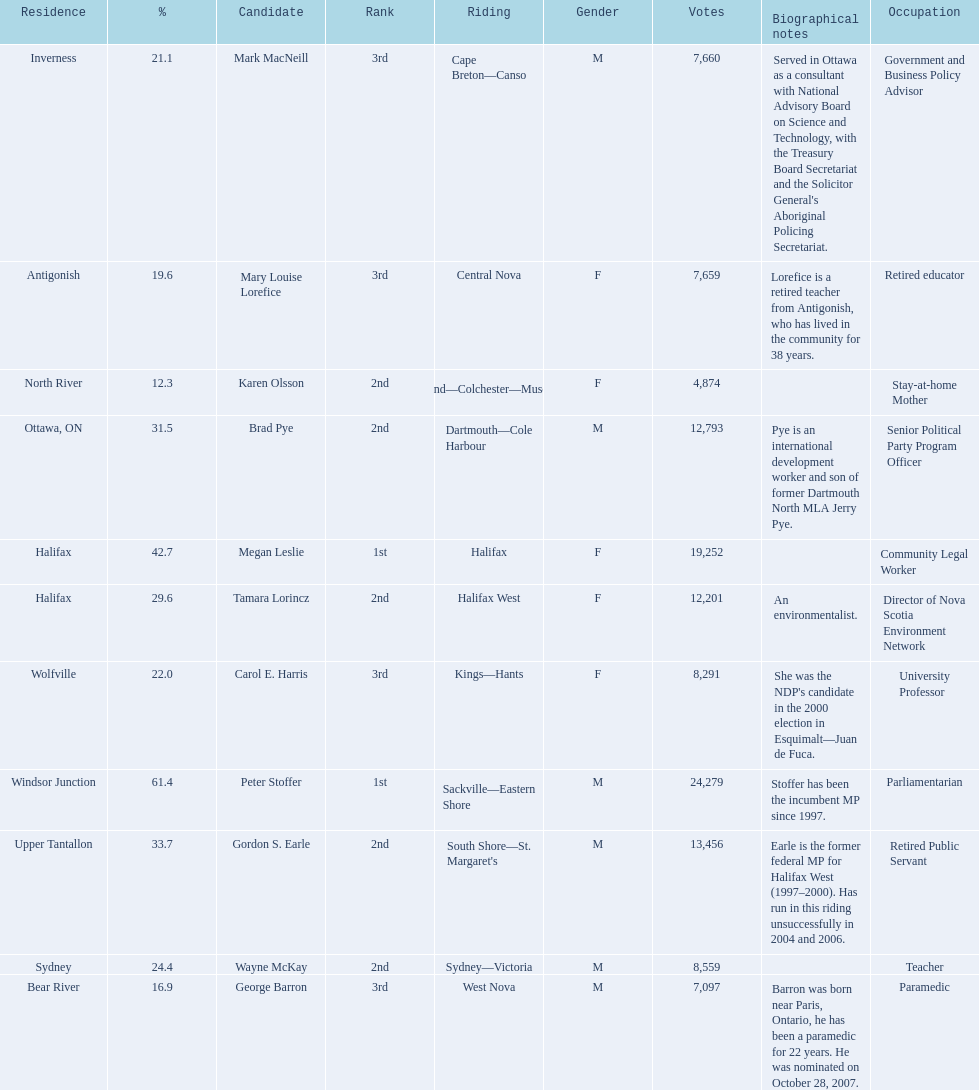Who were the new democratic party candidates, 2008? Mark MacNeill, Mary Louise Lorefice, Karen Olsson, Brad Pye, Megan Leslie, Tamara Lorincz, Carol E. Harris, Peter Stoffer, Gordon S. Earle, Wayne McKay, George Barron. Who had the 2nd highest number of votes? Megan Leslie, Peter Stoffer. How many votes did she receive? 19,252. 